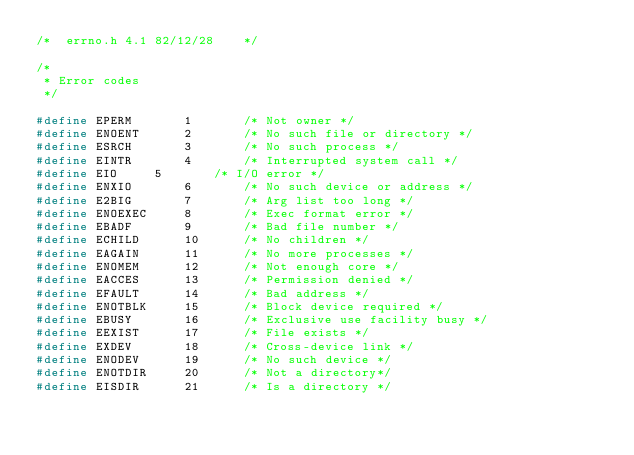Convert code to text. <code><loc_0><loc_0><loc_500><loc_500><_C_>/*	errno.h	4.1	82/12/28	*/

/*
 * Error codes
 */

#define	EPERM		1		/* Not owner */
#define	ENOENT		2		/* No such file or directory */
#define	ESRCH		3		/* No such process */
#define	EINTR		4		/* Interrupted system call */
#define	EIO		5		/* I/O error */
#define	ENXIO		6		/* No such device or address */
#define	E2BIG		7		/* Arg list too long */
#define	ENOEXEC		8		/* Exec format error */
#define	EBADF		9		/* Bad file number */
#define	ECHILD		10		/* No children */
#define	EAGAIN		11		/* No more processes */
#define	ENOMEM		12		/* Not enough core */
#define	EACCES		13		/* Permission denied */
#define	EFAULT		14		/* Bad address */
#define	ENOTBLK		15		/* Block device required */
#define	EBUSY		16		/* Exclusive use facility busy */
#define	EEXIST		17		/* File exists */
#define	EXDEV		18		/* Cross-device link */
#define	ENODEV		19		/* No such device */
#define	ENOTDIR		20		/* Not a directory*/
#define	EISDIR		21		/* Is a directory */</code> 